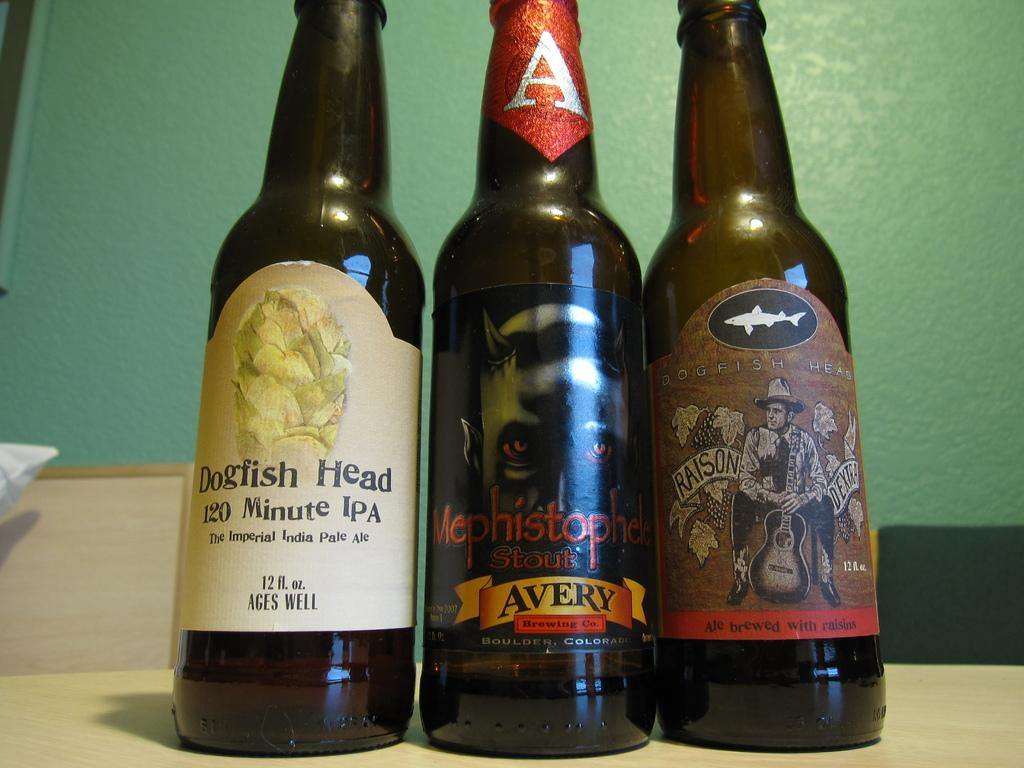Provide a one-sentence caption for the provided image. Three bottles of beer, with labels displaying brand names such as Dogfish Head, are lined up on a counter in front of a green wall. 